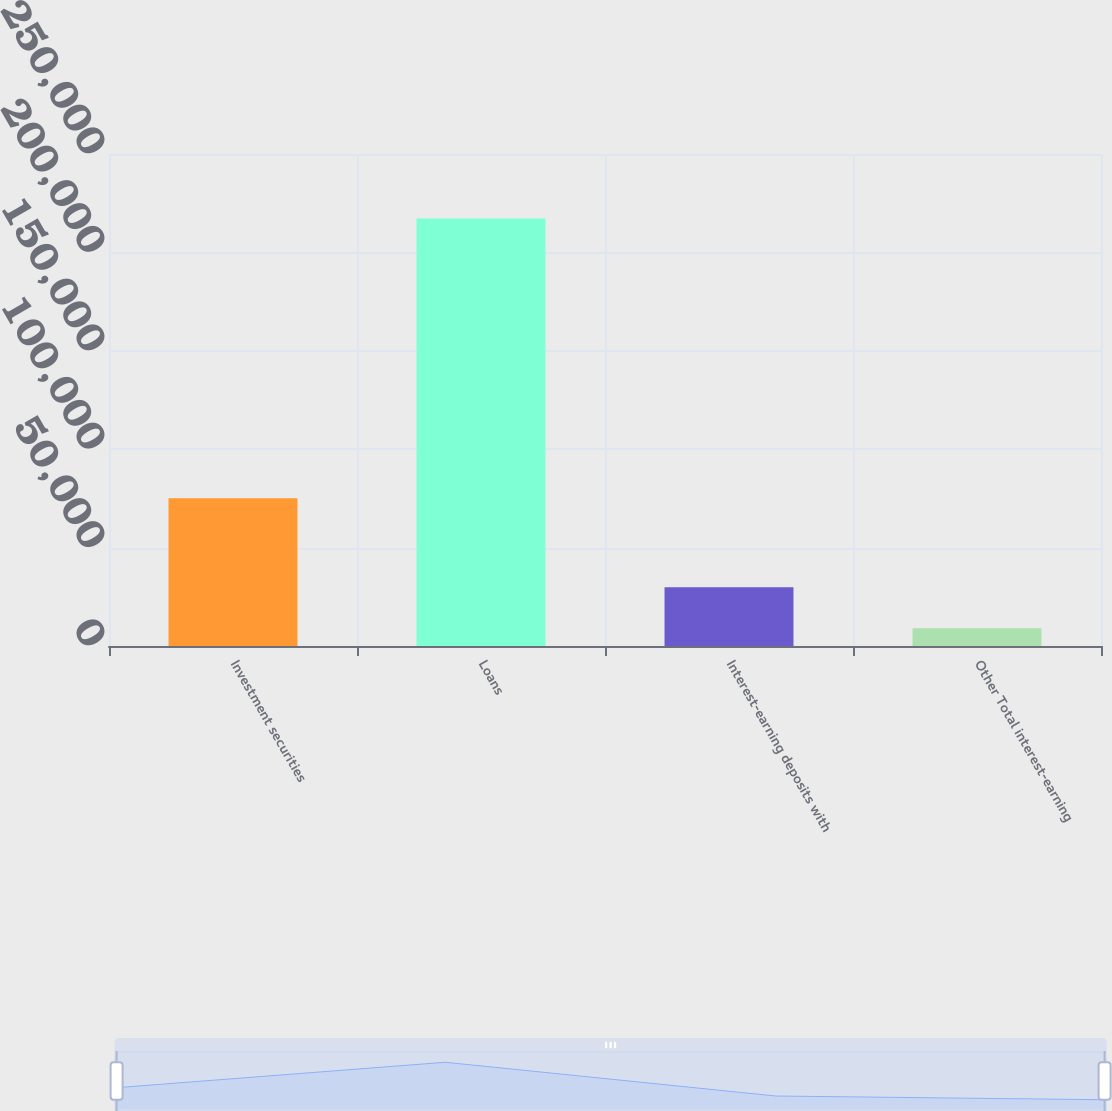Convert chart. <chart><loc_0><loc_0><loc_500><loc_500><bar_chart><fcel>Investment securities<fcel>Loans<fcel>Interest-earning deposits with<fcel>Other Total interest-earning<nl><fcel>75057<fcel>217271<fcel>29811.8<fcel>8983<nl></chart> 